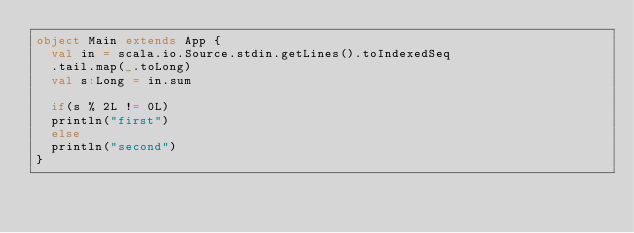Convert code to text. <code><loc_0><loc_0><loc_500><loc_500><_Scala_>object Main extends App {
  val in = scala.io.Source.stdin.getLines().toIndexedSeq
  .tail.map(_.toLong)
  val s:Long = in.sum
  
  if(s % 2L != 0L)
  println("first")
  else
  println("second")	
}
</code> 